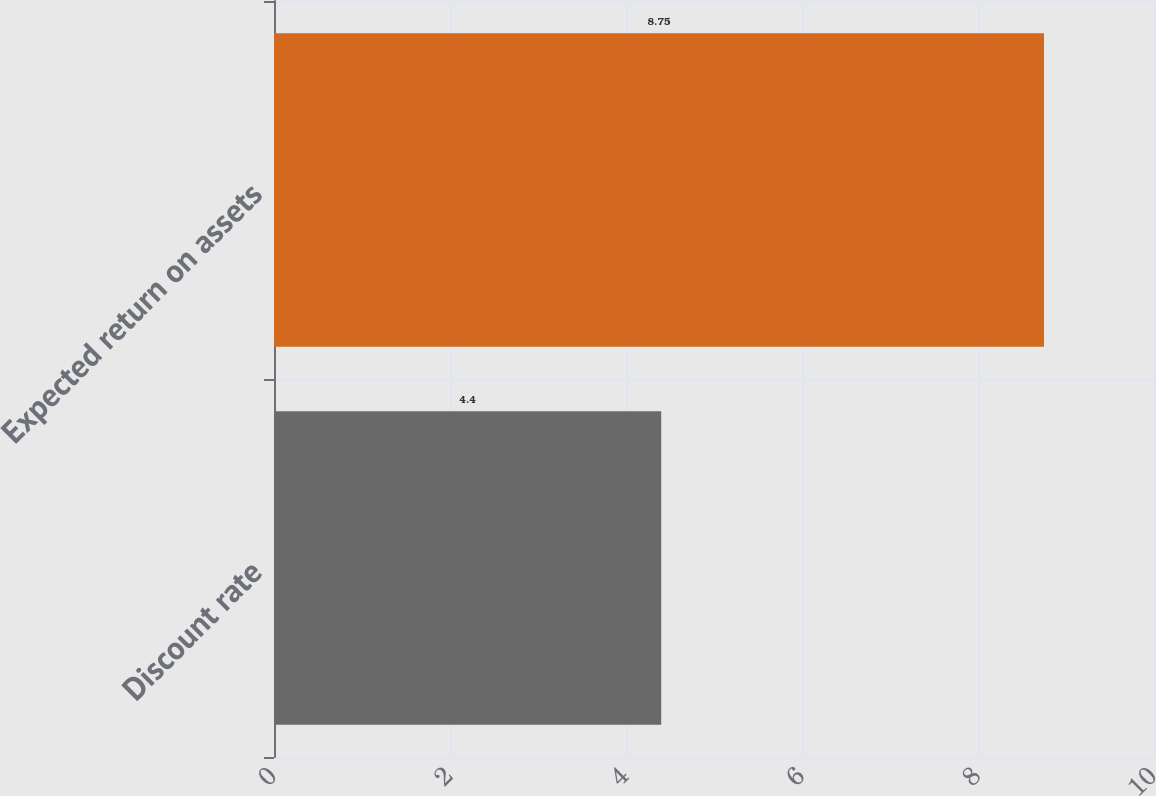<chart> <loc_0><loc_0><loc_500><loc_500><bar_chart><fcel>Discount rate<fcel>Expected return on assets<nl><fcel>4.4<fcel>8.75<nl></chart> 